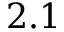Convert formula to latex. <formula><loc_0><loc_0><loc_500><loc_500>2 . 1</formula> 